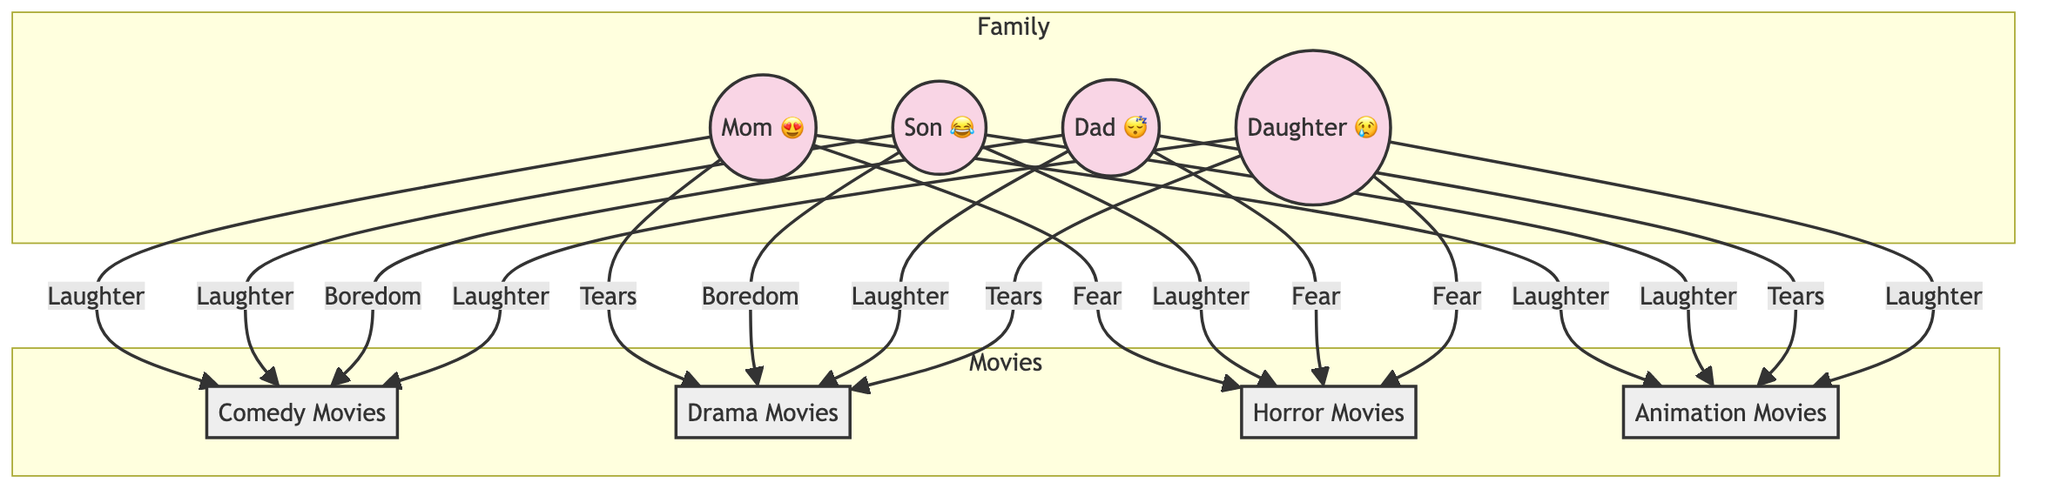What's the overall emotion of Dad during comedy movies? According to the diagram, Dad shows "Boredom" when watching Comedy Movies, as indicated by the arrow connecting him to the Comedy Movies node with the label "Boredom."
Answer: Boredom Which movie genre makes the Son laugh the most? The diagram shows that the Son reacts with "Laughter" to both Comedy and Animation Movies, but the inquiry focuses on which genre produces the maximum laughter. Since both genres are tied here, the answer reflects the immediate data.
Answer: Comedy or Animation How many emotions does Mom express in the Drama genre? The diagram indicates that Mom expresses "Tears" in Drama Movies, which counts as one emotion. Therefore, the answer is based on the single arrow connecting her to the Drama node with the label "Tears."
Answer: 1 What emotion does the Daughter exhibit during Horror films? In the diagram, the Daughter experiences "Fear" during Horror Movies, as shown by the arrow connecting her to the Horror node with the label "Fear."
Answer: Fear What is the total number of emotions expressed by family members in Animation movies? The diagram reveals the following emotions in Animation Movies: Mom shows "Laughter," Son shows "Laughter," Dad shows "Tears," and Daughter shows "Laughter." Counting these, there are four emotions expressed by family members.
Answer: 4 Which family member is bored during Drama films? In the diagram, the only family member who displays the emotion of "Boredom" in the Drama genre is the Son, as indicated by the arrow going to the Drama node labeled "Boredom."
Answer: Son What emotion does Mom show during Comedy movies? The diagram clearly states that Mom expresses "Laughter" during Comedy Movies, evidenced by the connection between her and the Comedy node labeled "Laughter."
Answer: Laughter How many family members cried during Drama movies? The diagram shows that only the Daughter exhibits "Tears" during Drama Movies, as indicated by the arrow from her to the Drama node labeled "Tears." Thus, we conclude there's only one member showing this emotion.
Answer: 1 